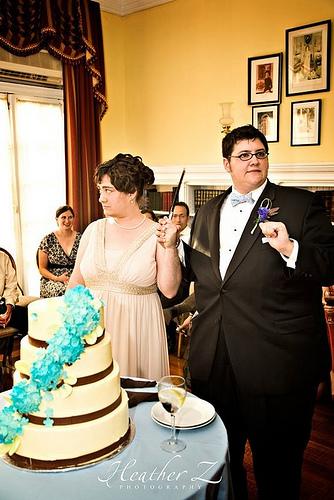What color is the brides dress?
Keep it brief. Beige. What is the most prominent decoration on the cake?
Answer briefly. Flowers. Is the couple the same race?
Short answer required. Yes. Do they look happy?
Write a very short answer. No. What occasion is this?
Give a very brief answer. Wedding. How many layers is this cake?
Short answer required. 4. Do the curtains and lighting in this room look modern or old fashioned?
Quick response, please. Old fashioned. How many tiers is the cake?
Write a very short answer. 4. 